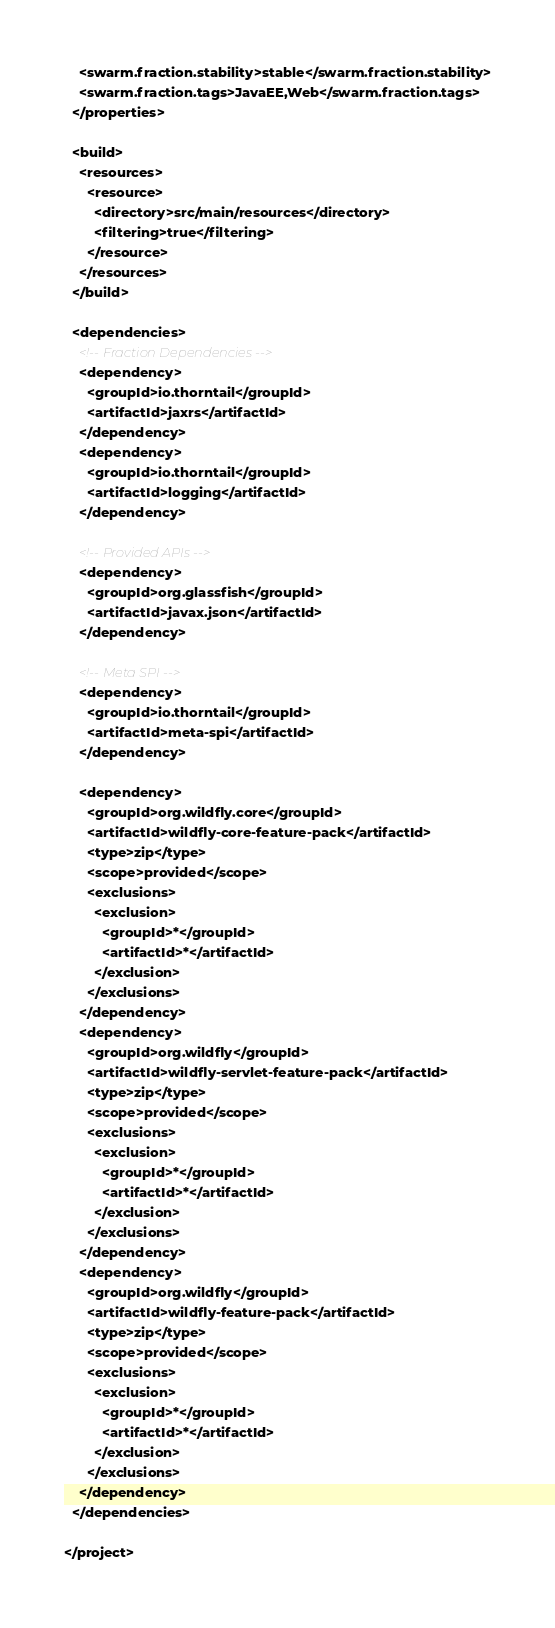<code> <loc_0><loc_0><loc_500><loc_500><_XML_>    <swarm.fraction.stability>stable</swarm.fraction.stability>
    <swarm.fraction.tags>JavaEE,Web</swarm.fraction.tags>
  </properties>

  <build>
    <resources>
      <resource>
        <directory>src/main/resources</directory>
        <filtering>true</filtering>
      </resource>
    </resources>
  </build>

  <dependencies>
    <!-- Fraction Dependencies -->
    <dependency>
      <groupId>io.thorntail</groupId>
      <artifactId>jaxrs</artifactId>
    </dependency>
    <dependency>
      <groupId>io.thorntail</groupId>
      <artifactId>logging</artifactId>
    </dependency>

    <!-- Provided APIs -->
    <dependency>
      <groupId>org.glassfish</groupId>
      <artifactId>javax.json</artifactId>
    </dependency>

    <!-- Meta SPI -->
    <dependency>
      <groupId>io.thorntail</groupId>
      <artifactId>meta-spi</artifactId>
    </dependency>

    <dependency>
      <groupId>org.wildfly.core</groupId>
      <artifactId>wildfly-core-feature-pack</artifactId>
      <type>zip</type>
      <scope>provided</scope>
      <exclusions>
        <exclusion>
          <groupId>*</groupId>
          <artifactId>*</artifactId>
        </exclusion>
      </exclusions>
    </dependency>
    <dependency>
      <groupId>org.wildfly</groupId>
      <artifactId>wildfly-servlet-feature-pack</artifactId>
      <type>zip</type>
      <scope>provided</scope>
      <exclusions>
        <exclusion>
          <groupId>*</groupId>
          <artifactId>*</artifactId>
        </exclusion>
      </exclusions>
    </dependency>
    <dependency>
      <groupId>org.wildfly</groupId>
      <artifactId>wildfly-feature-pack</artifactId>
      <type>zip</type>
      <scope>provided</scope>
      <exclusions>
        <exclusion>
          <groupId>*</groupId>
          <artifactId>*</artifactId>
        </exclusion>
      </exclusions>
    </dependency>
  </dependencies>

</project>
</code> 